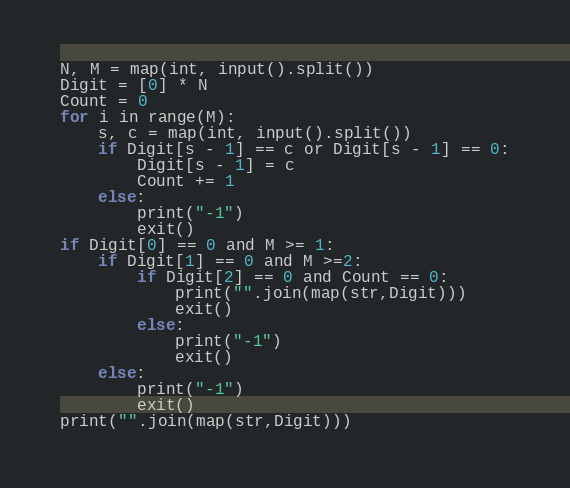<code> <loc_0><loc_0><loc_500><loc_500><_Python_>N, M = map(int, input().split())
Digit = [0] * N
Count = 0
for i in range(M):
    s, c = map(int, input().split())
    if Digit[s - 1] == c or Digit[s - 1] == 0:
        Digit[s - 1] = c
        Count += 1
    else:
        print("-1")
        exit()
if Digit[0] == 0 and M >= 1:
    if Digit[1] == 0 and M >=2:
        if Digit[2] == 0 and Count == 0:
            print("".join(map(str,Digit)))
            exit()
        else:
            print("-1")
            exit()
    else:
        print("-1")
        exit()
print("".join(map(str,Digit)))</code> 